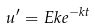<formula> <loc_0><loc_0><loc_500><loc_500>u ^ { \prime } = E k e ^ { - k t }</formula> 